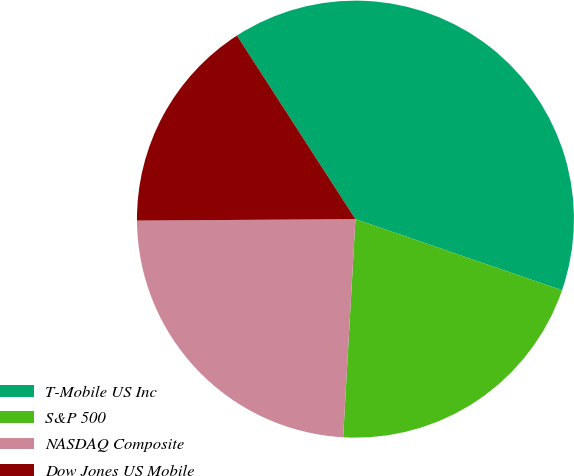Convert chart. <chart><loc_0><loc_0><loc_500><loc_500><pie_chart><fcel>T-Mobile US Inc<fcel>S&P 500<fcel>NASDAQ Composite<fcel>Dow Jones US Mobile<nl><fcel>39.4%<fcel>20.62%<fcel>24.0%<fcel>15.98%<nl></chart> 